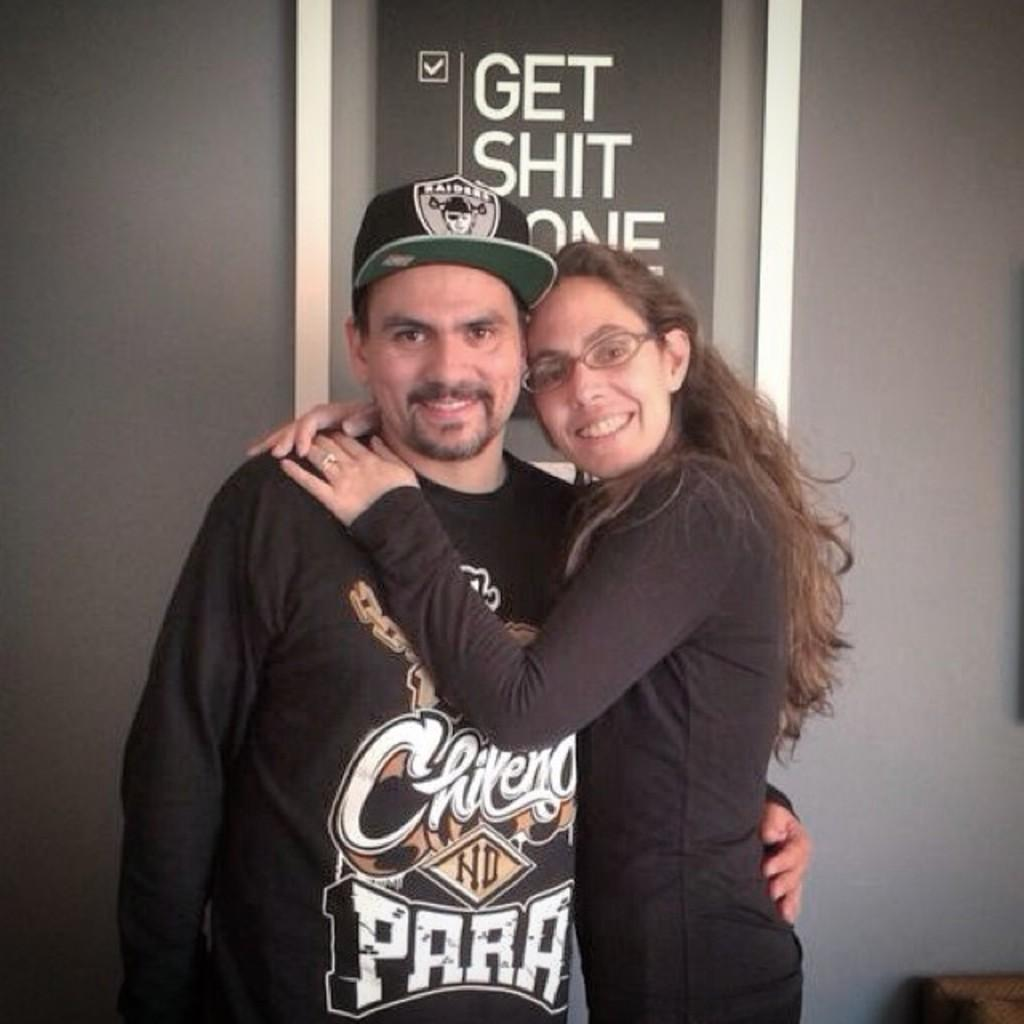<image>
Present a compact description of the photo's key features. a man and lady hugging with the word get behind them 